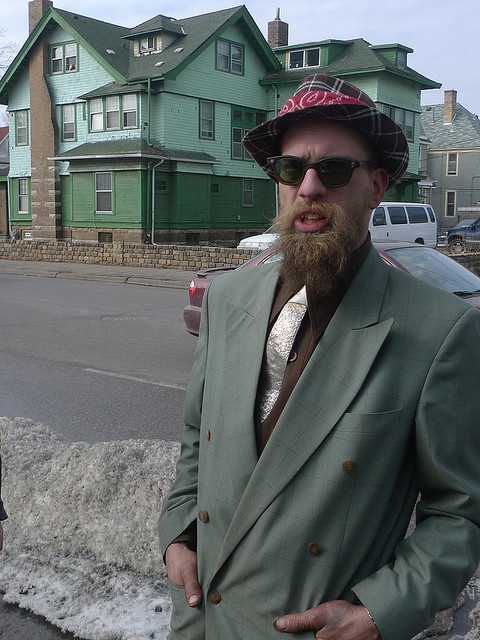Describe the objects in this image and their specific colors. I can see people in lavender, gray, black, and purple tones, car in lavender, gray, and darkgray tones, car in lavender, darkgray, gray, darkblue, and navy tones, tie in lavender, darkgray, lightgray, gray, and black tones, and car in lavender, gray, black, navy, and blue tones in this image. 